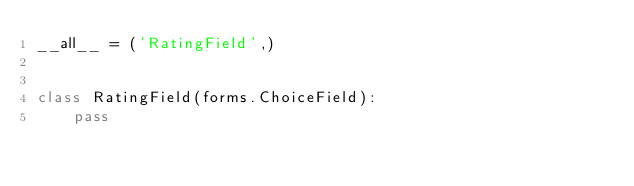Convert code to text. <code><loc_0><loc_0><loc_500><loc_500><_Python_>__all__ = ('RatingField',)


class RatingField(forms.ChoiceField):
    pass
</code> 